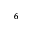<formula> <loc_0><loc_0><loc_500><loc_500>^ { 6 }</formula> 